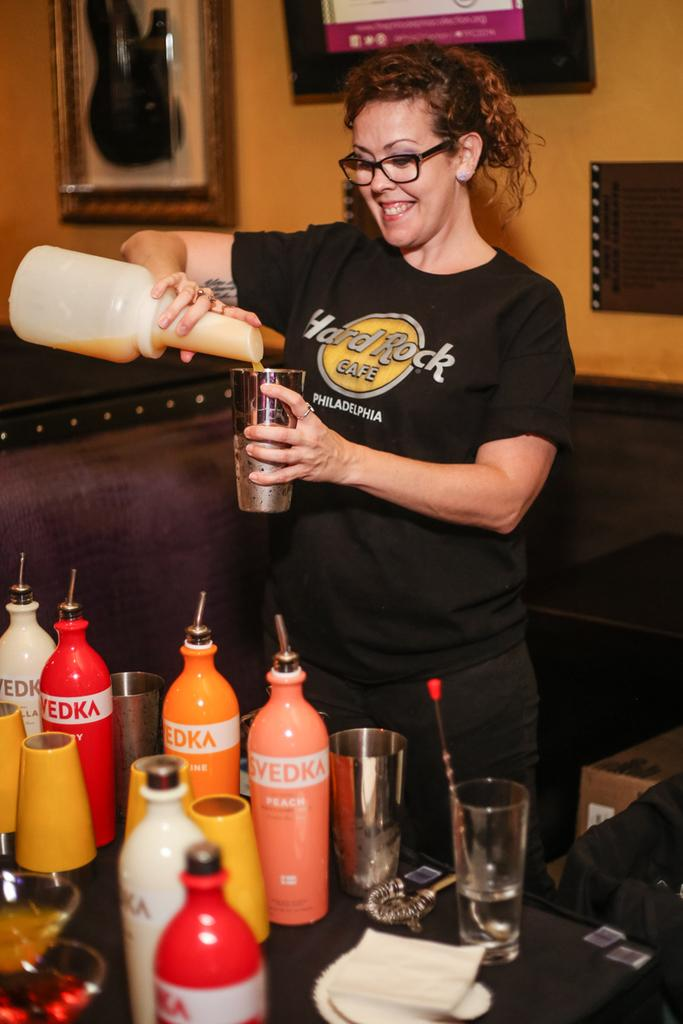Provide a one-sentence caption for the provided image. A bottle of Svedka peach sits in front of a woman making drinks. 